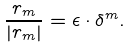<formula> <loc_0><loc_0><loc_500><loc_500>\frac { r _ { m } } { | r _ { m } | } = \epsilon \cdot \delta ^ { m } .</formula> 